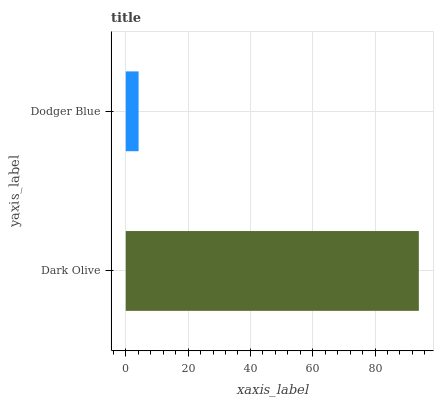Is Dodger Blue the minimum?
Answer yes or no. Yes. Is Dark Olive the maximum?
Answer yes or no. Yes. Is Dodger Blue the maximum?
Answer yes or no. No. Is Dark Olive greater than Dodger Blue?
Answer yes or no. Yes. Is Dodger Blue less than Dark Olive?
Answer yes or no. Yes. Is Dodger Blue greater than Dark Olive?
Answer yes or no. No. Is Dark Olive less than Dodger Blue?
Answer yes or no. No. Is Dark Olive the high median?
Answer yes or no. Yes. Is Dodger Blue the low median?
Answer yes or no. Yes. Is Dodger Blue the high median?
Answer yes or no. No. Is Dark Olive the low median?
Answer yes or no. No. 